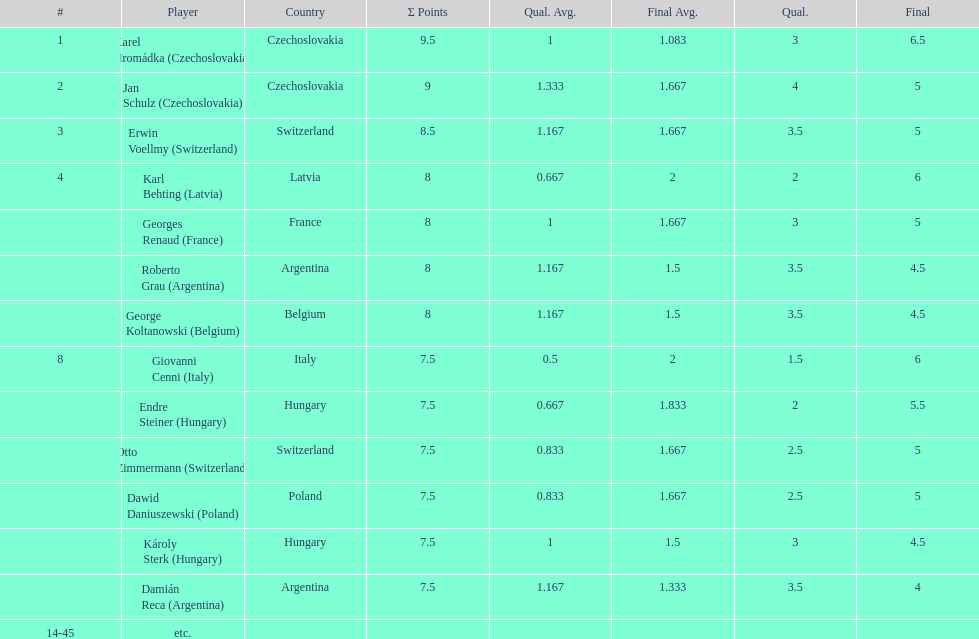Did the two competitors from hungary get more or less combined points than the two competitors from argentina? Less. Can you parse all the data within this table? {'header': ['#', 'Player', 'Country', 'Σ Points', 'Qual. Avg.', 'Final Avg.', 'Qual.', 'Final'], 'rows': [['1', 'Karel Hromádka\xa0(Czechoslovakia)', 'Czechoslovakia', '9.5', '1', '1.083', '3', '6.5'], ['2', 'Jan Schulz\xa0(Czechoslovakia)', 'Czechoslovakia', '9', '1.333', '1.667', '4', '5'], ['3', 'Erwin Voellmy\xa0(Switzerland)', 'Switzerland', '8.5', '1.167', '1.667', '3.5', '5'], ['4', 'Karl Behting\xa0(Latvia)', 'Latvia', '8', '0.667', '2', '2', '6'], ['', 'Georges Renaud\xa0(France)', 'France', '8', '1', '1.667', '3', '5'], ['', 'Roberto Grau\xa0(Argentina)', 'Argentina', '8', '1.167', '1.5', '3.5', '4.5'], ['', 'George Koltanowski\xa0(Belgium)', 'Belgium', '8', '1.167', '1.5', '3.5', '4.5'], ['8', 'Giovanni Cenni\xa0(Italy)', 'Italy', '7.5', '0.5', '2', '1.5', '6'], ['', 'Endre Steiner\xa0(Hungary)', 'Hungary', '7.5', '0.667', '1.833', '2', '5.5'], ['', 'Otto Zimmermann\xa0(Switzerland)', 'Switzerland', '7.5', '0.833', '1.667', '2.5', '5'], ['', 'Dawid Daniuszewski\xa0(Poland)', 'Poland', '7.5', '0.833', '1.667', '2.5', '5'], ['', 'Károly Sterk\xa0(Hungary)', 'Hungary', '7.5', '1', '1.5', '3', '4.5'], ['', 'Damián Reca\xa0(Argentina)', 'Argentina', '7.5', '1.167', '1.333', '3.5', '4'], ['14-45', 'etc.', '', '', '', '', '', '']]} 